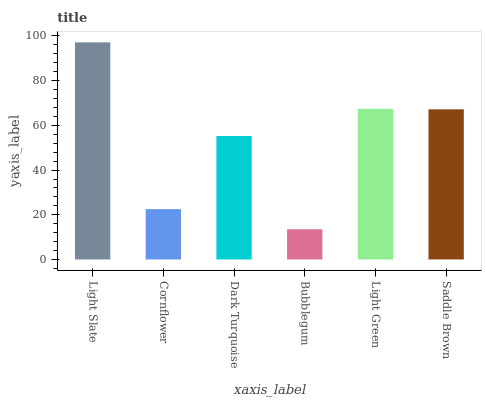Is Bubblegum the minimum?
Answer yes or no. Yes. Is Light Slate the maximum?
Answer yes or no. Yes. Is Cornflower the minimum?
Answer yes or no. No. Is Cornflower the maximum?
Answer yes or no. No. Is Light Slate greater than Cornflower?
Answer yes or no. Yes. Is Cornflower less than Light Slate?
Answer yes or no. Yes. Is Cornflower greater than Light Slate?
Answer yes or no. No. Is Light Slate less than Cornflower?
Answer yes or no. No. Is Saddle Brown the high median?
Answer yes or no. Yes. Is Dark Turquoise the low median?
Answer yes or no. Yes. Is Bubblegum the high median?
Answer yes or no. No. Is Saddle Brown the low median?
Answer yes or no. No. 